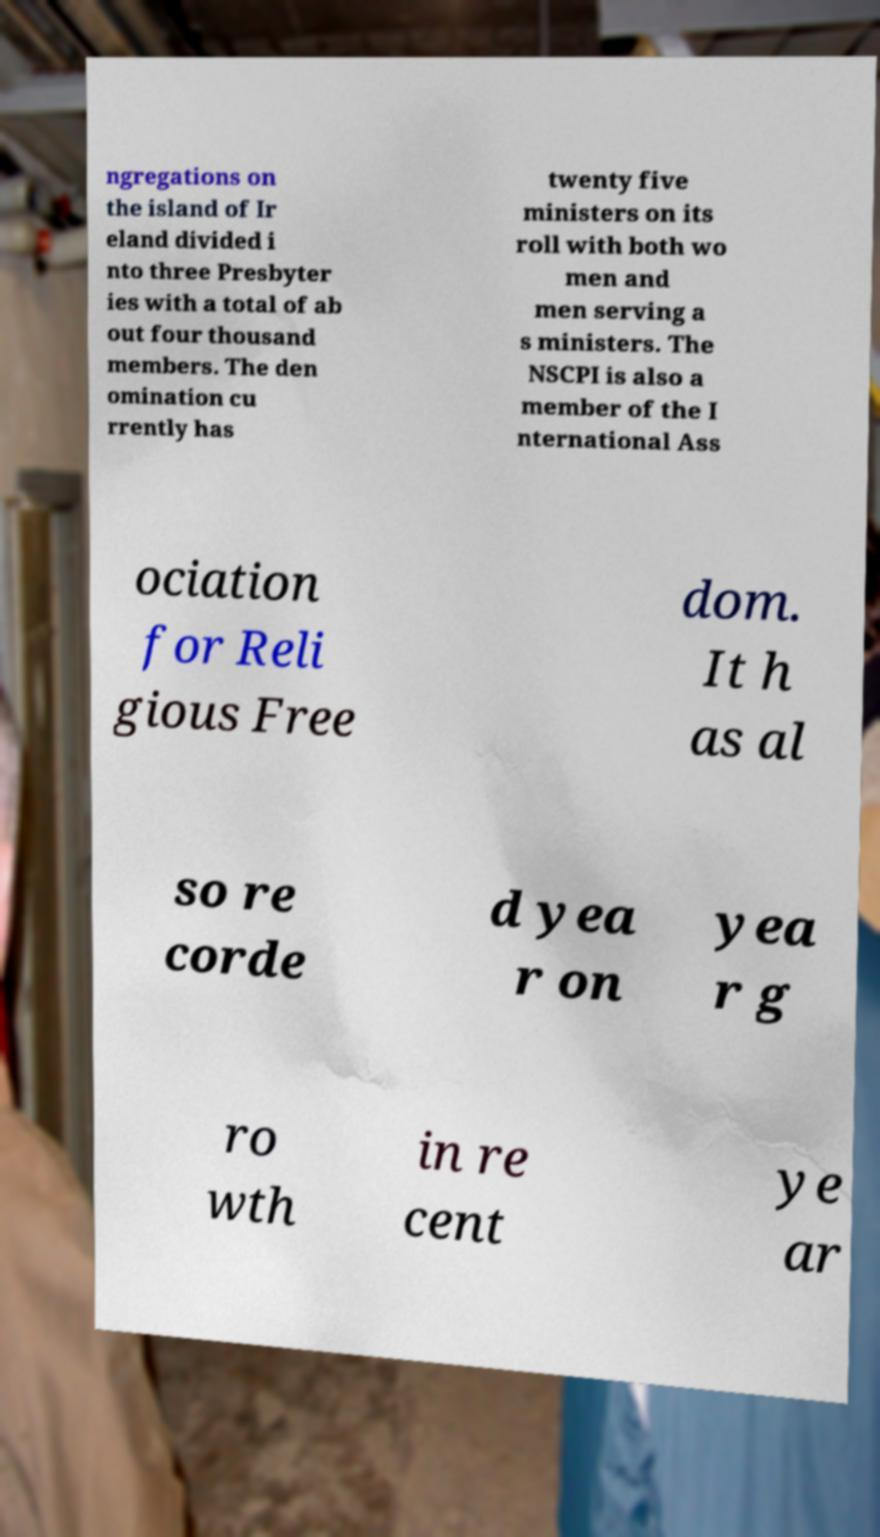Could you assist in decoding the text presented in this image and type it out clearly? ngregations on the island of Ir eland divided i nto three Presbyter ies with a total of ab out four thousand members. The den omination cu rrently has twenty five ministers on its roll with both wo men and men serving a s ministers. The NSCPI is also a member of the I nternational Ass ociation for Reli gious Free dom. It h as al so re corde d yea r on yea r g ro wth in re cent ye ar 